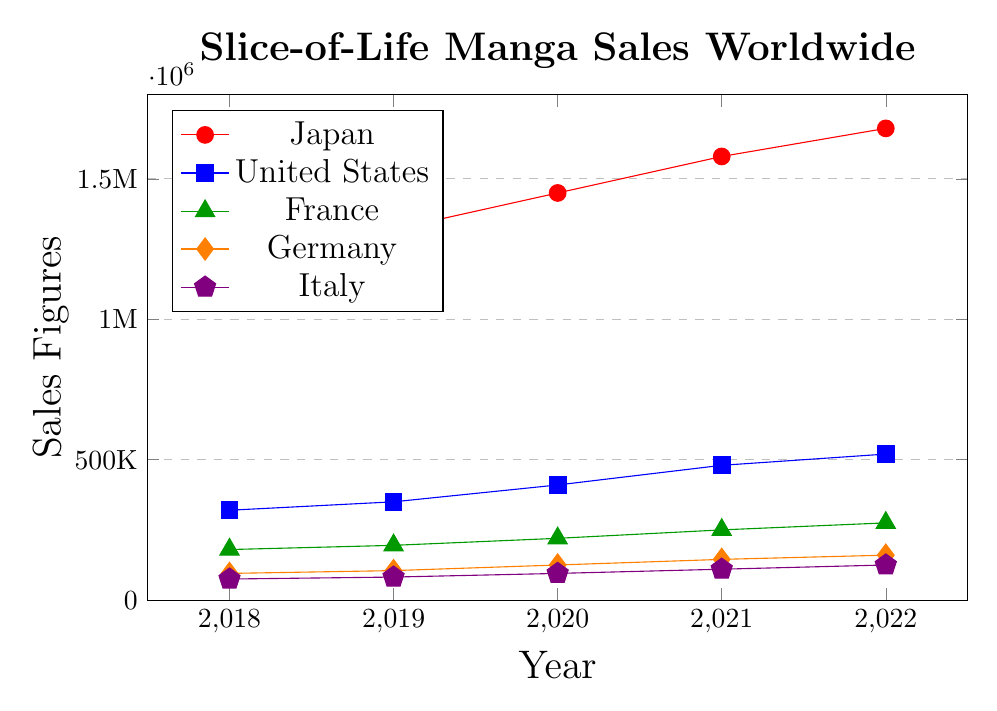Which country had the highest sales in 2021? To identify the highest sales in 2021, we look at the vertical position of each line for the year 2021. Japan has the highest value among all with sales figures hitting 1,580,000.
Answer: Japan Which countries showed an increase in sales every year from 2018 to 2022? To find which countries showed an increase each year, observe each line for a consistent upward trend from 2018 to 2022. All five countries—Japan, United States, France, Germany, and Italy—show a consistent increase in sales each year.
Answer: Japan, United States, France, Germany, Italy How much did the sales increase in Japan from 2019 to 2022? Calculate the difference in sales figures for Japan between 2019 and 2022: 1,680,000 - 1,320,000 = 360,000.
Answer: 360,000 Which country had the smallest sales figure in 2018 and what was it? To find the smallest sales figure in 2018, look at the data for that year. Italy has the smallest value with 75,000 sales.
Answer: Italy, 75,000 By how much did the United States' sales increase from 2018 to 2020? Calculate the difference in sales figures for the United States between 2018 and 2020: 410,000 - 320,000 = 90,000.
Answer: 90,000 Which country had the second highest sales figures in 2022? Identify the second highest point on the vertical axis for the year 2022. The United States is the second highest with 520,000.
Answer: United States What's the combined sales figure for Germany and Italy in 2022? Sum the sales figures of Germany and Italy for 2022: 160,000 + 125,000 = 285,000.
Answer: 285,000 Which country had the largest percentage increase in sales from 2018 to 2022? Calculate the percentage increase for each country from 2018 to 2022: 
- Japan: ((1,680,000 - 1,250,000) / 1,250,000) * 100 = 34.4%
- United States: ((520,000 - 320,000) / 320,000) * 100 = 62.5%
- France: ((275,000 - 180,000) / 180,000) * 100 = 52.8%
- Germany: ((160,000 - 95,000) / 95,000) * 100 = 68.4%
- Italy: ((125,000 - 75,000) / 75,000) * 100 = 66.7%
Germany has the largest percentage increase.
Answer: Germany How do the sales trends in Japan compare with those in the United States between 2018 and 2022? Both Japan and the United States show an upward trend, with Japan having a much steeper increase. While the sales in Japan increased by 430,000 from 2018 to 2022, the United States' sales increased by 200,000 in the same period.
Answer: Both increased, Japan more steeply What is the average annual sales figure for France over the period 2018 to 2022? Sum the sales figures for France from 2018 to 2022 and divide by the number of years: (180,000 + 195,000 + 220,000 + 250,000 + 275,000) / 5 = 1,120,000 / 5 = 224,000.
Answer: 224,000 